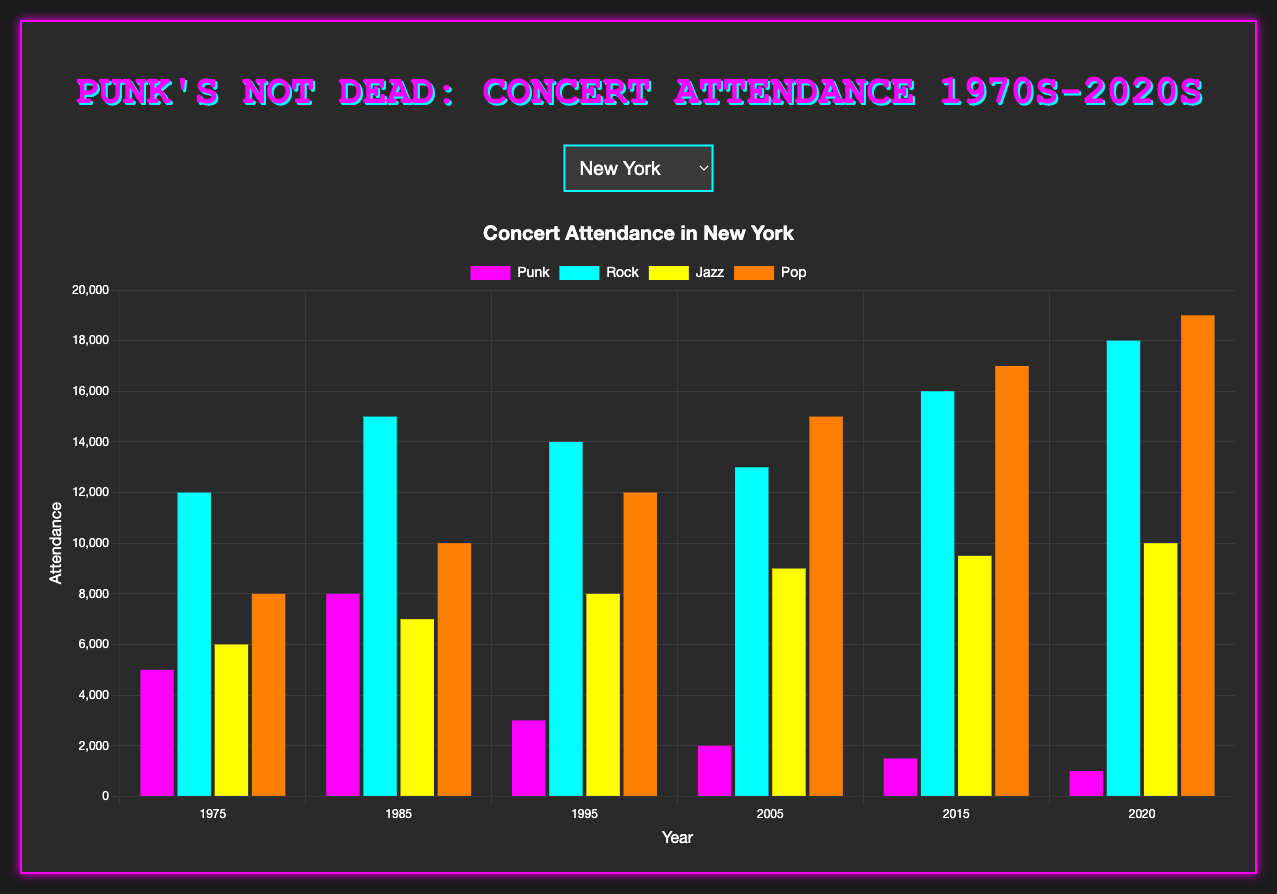Which city had higher punk concert attendance in 1985, New York or London? First locate the bars for punk attendance in 1985 for both New York and London. New York had 8000 attendees, London had 10000 attendees. Thus, London had higher attendance.
Answer: London What's the difference in rock concert attendance between New York in 2005 and 2020? Look at the bars representing rock attendance for New York in 2005 and 2020. In 2005, there were 13000 attendees and in 2020, there were 18000 attendees. Difference is 18000 - 13000 = 5000.
Answer: 5000 What was the trend in pop concert attendance in Los Angeles from 2015 to 2020? Identify the pop attendance for Los Angeles in 2015 and 2020. In 2015, it was 18000 and in 2020, it was 19000. The attendance increased from 2015 to 2020.
Answer: Increased Which genre had the lowest attendance in Berlin in 1995? Look at the bars representing different genres in Berlin for 1995. Punk had 3000 attendees, the lowest among the genres.
Answer: Punk In which year did Tokyo have the highest jazz concert attendance? Check the heights of the bars representing jazz in Tokyo across all years. The highest is 11000 in 2020.
Answer: 2020 Calculate the average punk concert attendance in New York for the 1975 and 1985. The punk attendance in 1975 is 5000 and in 1985 is 8000. Average = (5000 + 8000) / 2 = 6500.
Answer: 6500 Compare the rock concert attendance between Berlin and New York in 2015. Which city had higher attendance? For 2015, Berlin had 15500 and New York had 16000 attendees for rock. New York had higher attendance.
Answer: New York By what percentage did punk concert attendance in Berlin decrease from 1985 to 2020? Attendance in 1985: 8500, in 2020: 900. Percentage decrease = [(8500 - 900) / 8500] * 100 ≈ 89.41%.
Answer: 89.41% Which genre in London showed an increase in attendance from 2005 to 2015? Compare the attendance bars for each genre in London between 2005 and 2015. Rock attendance increased from 14000 to 17000.
Answer: Rock Summarize the trend for punk concert attendance in New York from 1975 to 2020. Look at the punk attendance bars for New York from 1975 to 2020; the attendance declined from 5000 to 1000, showing a decreasing trend.
Answer: Decreasing 